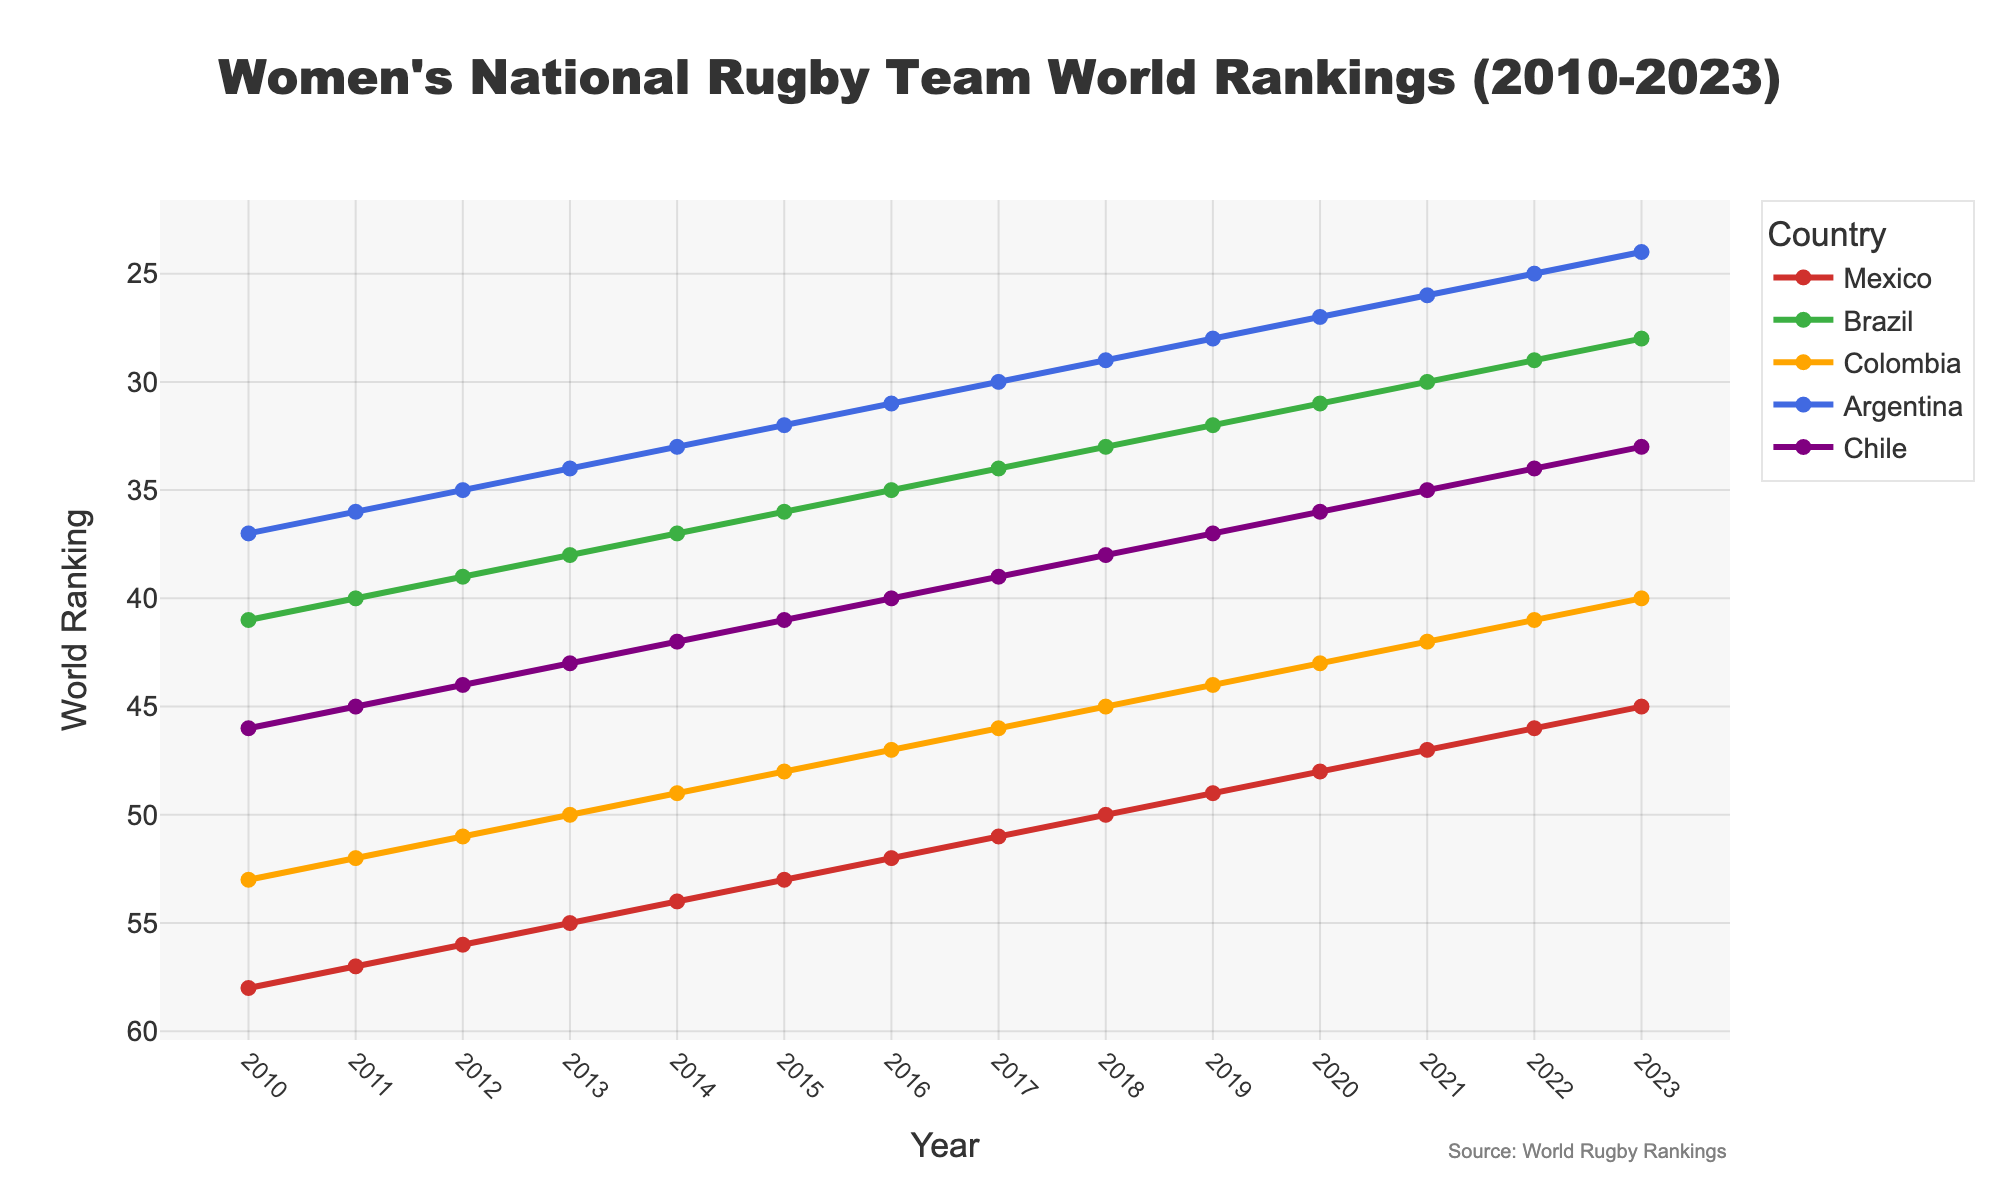Which country saw the greatest improvement in world rankings from 2010 to 2023? To determine the greatest improvement, calculate the difference in rankings from 2010 to 2023 for each country. The differences are: Mexico (58-45=13), Brazil (41-28=13), Colombia (53-40=13), Argentina (37-24=13), and Chile (46-33=13). All countries improved equally by 13 ranks.
Answer: All countries improved by 13 ranks In which year did Mexico have exactly the same world ranking as in 2023? From the figure, we see that Mexico had a world ranking of 45 in 2023. Find the year(s) where the ranking is also 45.
Answer: Only in 2023 Which country had the lowest world ranking in 2011? From the figure, check the rankings for all countries in 2011. Brazil had a ranking of 40, Colombia 52, Argentina 36, Chile 45, and Mexico 57.
Answer: Mexico Rank the countries based on their 2023 ranking from best to worst. Check the 2023 rankings for each country: Brazil (28), Colombia (40), Argentina (24), Chile (33), and Mexico (45). Rank them from best (lowest number) to worst (highest number).
Answer: Argentina, Brazil, Chile, Colombia, Mexico Did any country's ranking remain constant in any year? Check the lines for each country in the graph to see if any ranking remained flat for a period. None of the lines for the countries remain flat at any point indicating that the rankings changed every year.
Answer: No Which country had the steepest decline in rankings from 2010 to 2011? To determine the steepest decline, calculate the drop in rankings from 2010 to 2011 for each country. Brazil (41-40=1), Colombia (53-52=1), Argentina (37-36=1), Chile (46-45=1), Mexico (58-57=1). Since all declines are equal, there is no single steepest decline.
Answer: All countries had equal declines How did Argentina's world ranking change from 2010 to 2015? Look at the graph and note Argentina's world ranking in 2010 (37) and in 2015 (32). Calculate the difference (37-32=5).
Answer: Improved by 5 ranks What is the average ranking of Chile between 2010 and 2023? Sum all the rankings of Chile from 2010 to 2023 and then divide by the number of years (14). (46+45+44+43+42+41+40+39+38+37+36+35+34+33)/14 = 39
Answer: 39 Which country had the biggest improvement in ranking between 2015 and 2020? Calculate the difference in rankings from 2015 to 2020 for each country. Mexico (53-48=5), Brazil (36-31=5), Colombia (48-43=5), Argentina (32-27=5), Chile (41-36=5).
Answer: All countries improved by 5 ranks Comparing Argentina and Brazil, which country had a better ranking consistently across the years? Compare the yearly rankings of Argentina and Brazil. Argentina consistently has a lower (better) ranking than Brazil from 2010 to 2023.
Answer: Argentina 